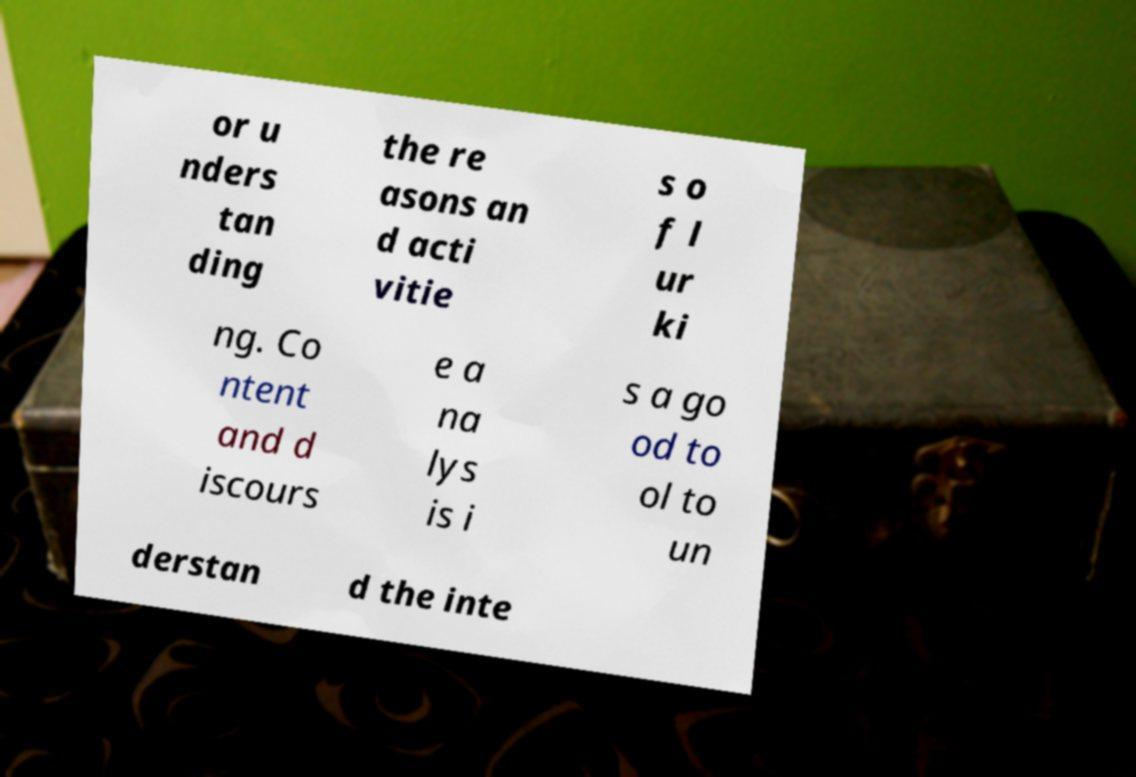Please identify and transcribe the text found in this image. or u nders tan ding the re asons an d acti vitie s o f l ur ki ng. Co ntent and d iscours e a na lys is i s a go od to ol to un derstan d the inte 